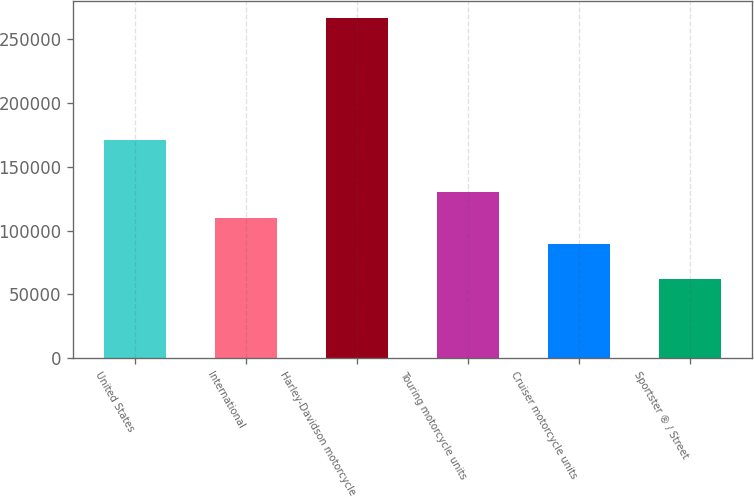Convert chart. <chart><loc_0><loc_0><loc_500><loc_500><bar_chart><fcel>United States<fcel>International<fcel>Harley-Davidson motorcycle<fcel>Touring motorcycle units<fcel>Cruiser motorcycle units<fcel>Sportster ® / Street<nl><fcel>170688<fcel>109604<fcel>266382<fcel>130002<fcel>89207<fcel>62407<nl></chart> 